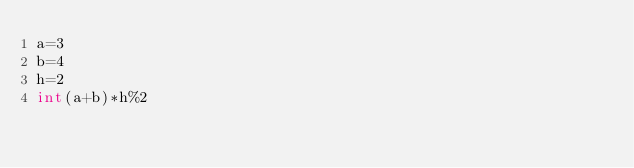Convert code to text. <code><loc_0><loc_0><loc_500><loc_500><_Python_>a=3
b=4
h=2
int(a+b)*h%2
</code> 